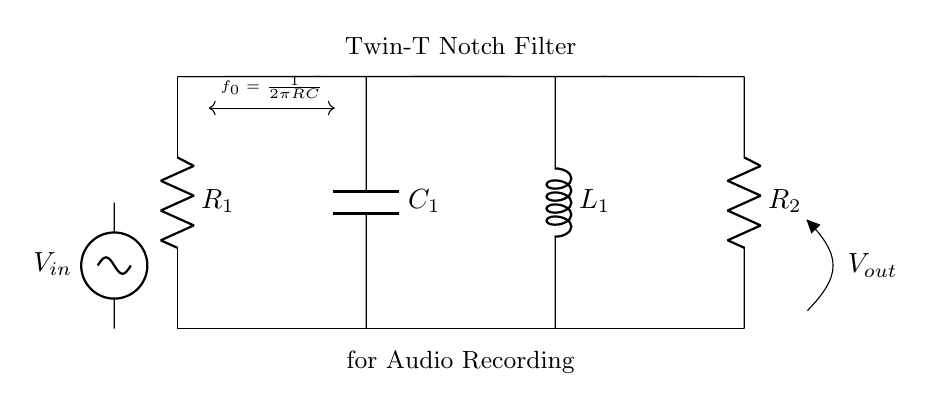What is the total number of resistors in this circuit? The diagram shows two resistors labeled as R1 and R2. Counting these components gives a total of two resistors.
Answer: 2 What type of filter is represented in this circuit? The circuit is labeled as a Twin-T Notch Filter, which is explicitly stated in the diagram.
Answer: Twin-T Notch Filter What is the role of capacitor C1 in the circuit? Capacitor C1 is part of the filter to block certain frequencies and is essential for tuning the notch frequency. The label indicates its importance in frequency filtering.
Answer: Frequency filtering What are the components connected between the input and output voltage? The circuit includes resistors R1, R2, capacitor C1, and inductor L1 connected between the input voltage source and the output labeled with Vout. These components work together to form the filter.
Answer: R1, R2, C1, L1 What is the expression for the notch frequency f0 in this filter? The diagram provides the expression for the notch frequency as f0 = 1 over 2 pi RC, indicating the relationship between resistance and capacitance in determining the frequency that will be attenuated.
Answer: 1 over 2 pi RC What does the output voltage Vout indicate in this circuit? The output voltage Vout shows the voltage after the signal has passed through the filter. It represents the audio signal that has had unwanted frequencies removed by the notch filter.
Answer: Audio signal 